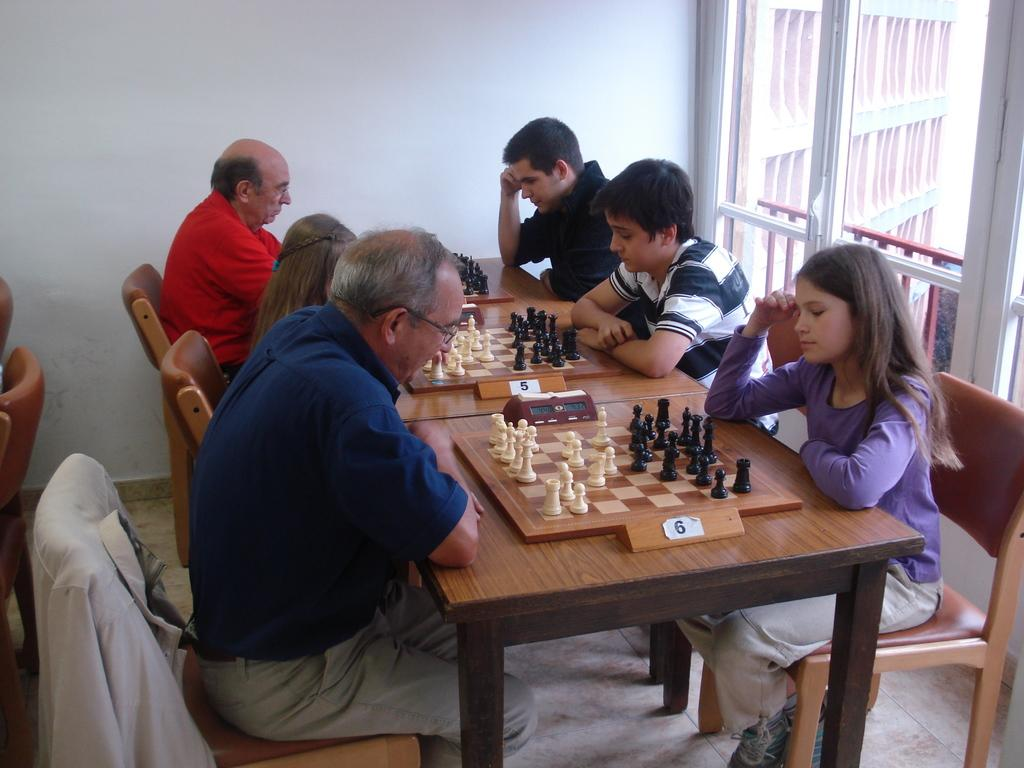How many people are sitting in the image? There are six people sitting on chairs in the image. What is on the table in the image? There is a chess board on the table in the image. What can be seen at the back side of the image? There is a wall at the back side of the image. Is there any source of natural light visible in the image? Yes, there is a window in the image. How does the earthquake affect the people sitting in the image? There is no earthquake present in the image, so its effects cannot be observed. What type of soda is being served in the image? There is no soda present in the image; the main object on the table is a chess board. 